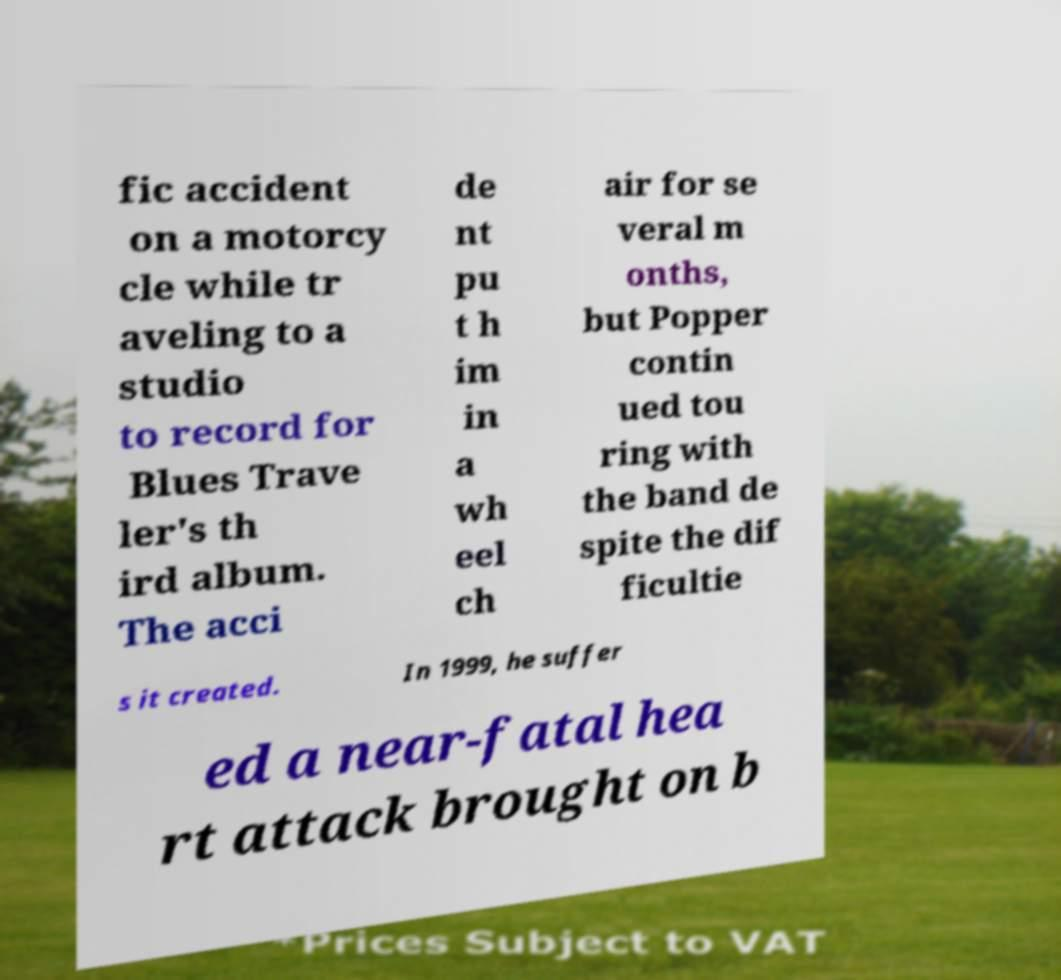I need the written content from this picture converted into text. Can you do that? fic accident on a motorcy cle while tr aveling to a studio to record for Blues Trave ler's th ird album. The acci de nt pu t h im in a wh eel ch air for se veral m onths, but Popper contin ued tou ring with the band de spite the dif ficultie s it created. In 1999, he suffer ed a near-fatal hea rt attack brought on b 